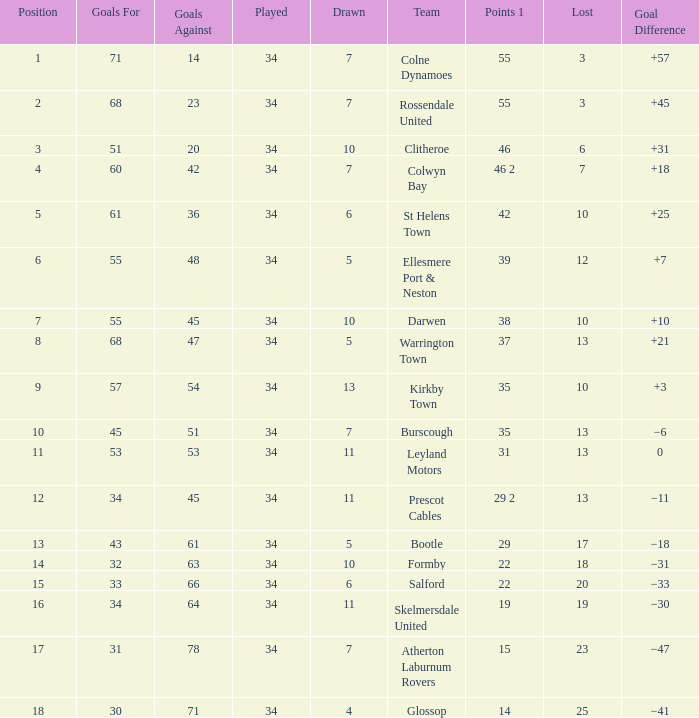Would you mind parsing the complete table? {'header': ['Position', 'Goals For', 'Goals Against', 'Played', 'Drawn', 'Team', 'Points 1', 'Lost', 'Goal Difference'], 'rows': [['1', '71', '14', '34', '7', 'Colne Dynamoes', '55', '3', '+57'], ['2', '68', '23', '34', '7', 'Rossendale United', '55', '3', '+45'], ['3', '51', '20', '34', '10', 'Clitheroe', '46', '6', '+31'], ['4', '60', '42', '34', '7', 'Colwyn Bay', '46 2', '7', '+18'], ['5', '61', '36', '34', '6', 'St Helens Town', '42', '10', '+25'], ['6', '55', '48', '34', '5', 'Ellesmere Port & Neston', '39', '12', '+7'], ['7', '55', '45', '34', '10', 'Darwen', '38', '10', '+10'], ['8', '68', '47', '34', '5', 'Warrington Town', '37', '13', '+21'], ['9', '57', '54', '34', '13', 'Kirkby Town', '35', '10', '+3'], ['10', '45', '51', '34', '7', 'Burscough', '35', '13', '−6'], ['11', '53', '53', '34', '11', 'Leyland Motors', '31', '13', '0'], ['12', '34', '45', '34', '11', 'Prescot Cables', '29 2', '13', '−11'], ['13', '43', '61', '34', '5', 'Bootle', '29', '17', '−18'], ['14', '32', '63', '34', '10', 'Formby', '22', '18', '−31'], ['15', '33', '66', '34', '6', 'Salford', '22', '20', '−33'], ['16', '34', '64', '34', '11', 'Skelmersdale United', '19', '19', '−30'], ['17', '31', '78', '34', '7', 'Atherton Laburnum Rovers', '15', '23', '−47'], ['18', '30', '71', '34', '4', 'Glossop', '14', '25', '−41']]} Which Goals For has a Played larger than 34? None. 